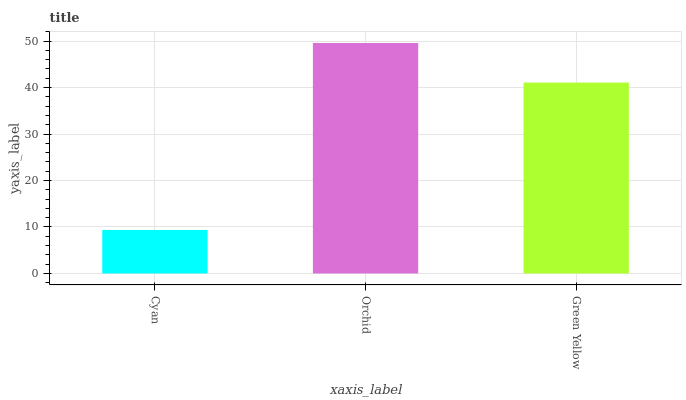Is Cyan the minimum?
Answer yes or no. Yes. Is Orchid the maximum?
Answer yes or no. Yes. Is Green Yellow the minimum?
Answer yes or no. No. Is Green Yellow the maximum?
Answer yes or no. No. Is Orchid greater than Green Yellow?
Answer yes or no. Yes. Is Green Yellow less than Orchid?
Answer yes or no. Yes. Is Green Yellow greater than Orchid?
Answer yes or no. No. Is Orchid less than Green Yellow?
Answer yes or no. No. Is Green Yellow the high median?
Answer yes or no. Yes. Is Green Yellow the low median?
Answer yes or no. Yes. Is Orchid the high median?
Answer yes or no. No. Is Cyan the low median?
Answer yes or no. No. 